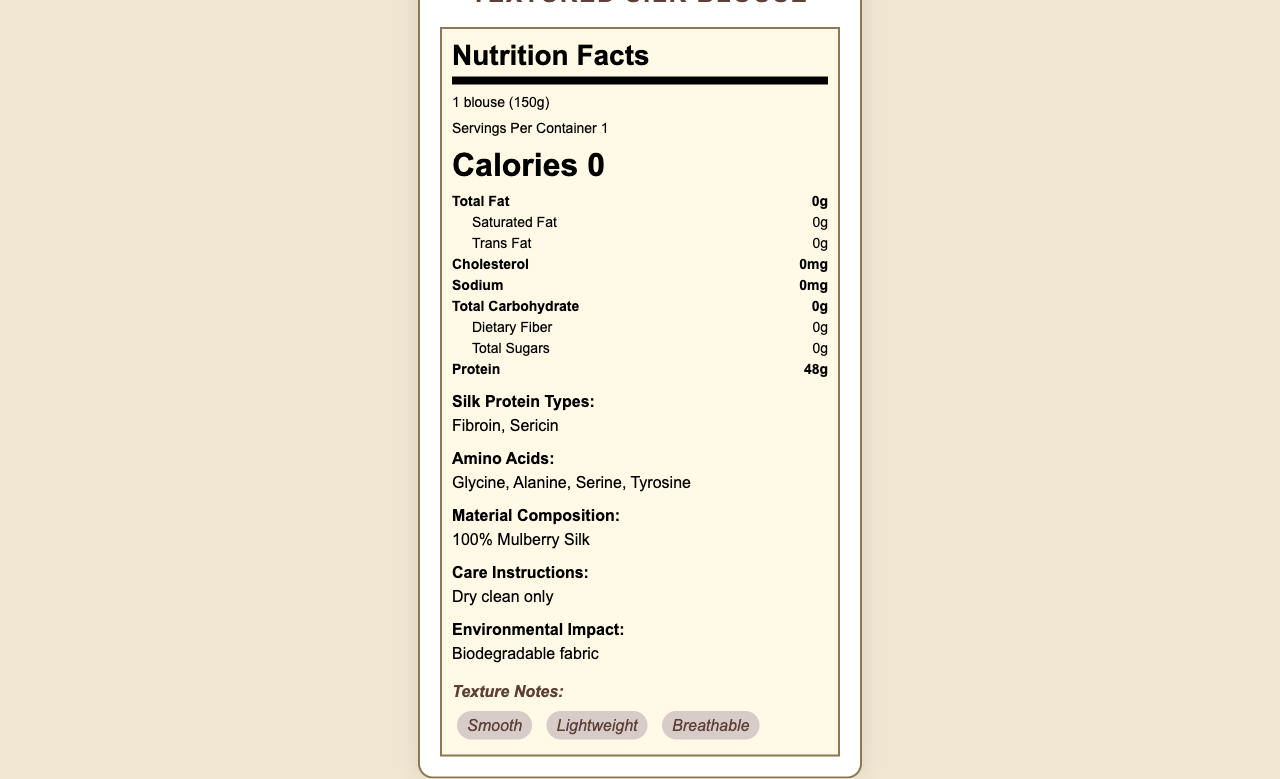what is the serving size of the Textured Silk Blouse? The serving size is explicitly mentioned at the top part of the nutrition label under the product name and nutrition facts header.
Answer: 1 blouse (150g) how much protein is in one serving? The amount of protein is listed under the nutrient section, showing "Protein 48g".
Answer: 48g are there any dietary fibers in this product? The nutrition label lists "Dietary Fiber" as 0g under the nutrient section.
Answer: No what are the main textures noted for the Textured Silk Blouse? The texture notes section highlights these properties accompanied by tags that describe smooth, lightweight, and breathable.
Answer: Smooth, Lightweight, Breathable what are the types of silk protein present? The section titled "Silk Protein Types" explicitly lists Fibroin and Sericin.
Answer: Fibroin, Sericin The Textured Silk Blouse contains which amino acids? The section titled "Amino Acids" lists these particular amino acids.
Answer: Glycine, Alanine, Serine, Tyrosine How many calories does the Textured Silk Blouse have? The calorie content is listed under the nutrition facts header and clearly states "Calories 0".
Answer: 0 Which of the following represents the correct material composition? A. 100% Cotton B. 50% Silk, 50% Cotton C. 100% Mulberry Silk The section titled "Material Composition" states the blouse is made of "100% Mulberry Silk".
Answer: C What is the care instruction provided for the Textured Silk Blouse? A. Machine wash only B. Hand-wash only C. Dry clean only The "Care Instructions" section mentions "Dry clean only".
Answer: C Is the Textured Silk Blouse hypoallergenic? The document includes a specific point mentioning that the blouse is hypoallergenic.
Answer: Yes Can the detailed origin of this product be determined? The section titled "Origin" states the exact origin of the product as "Ethically sourced from Suzhou, China".
Answer: Ethically sourced from Suzhou, China What is the environmental impact of the Textured Silk Blouse? The "Environmental Impact" section mentions that the fabric is biodegradable.
Answer: Biodegradable fabric Summarize the key nutritional information in the document. The summary focuses on the main nutritional content, highlighting the lack of typical nutrients found in food and emphasizing the high protein content and its composition.
Answer: The Textured Silk Blouse has no calories, fats, cholesterol, sodium, carbohydrates, sugars, or dietary fibers. However, it contains 48g of protein, comprising silk proteins like Fibroin and Sericin, with amino acids such as Glycine, Alanine, Serine, and Tyrosine. Is this product machine washable? The care instruction specified in the document says "Dry clean only," indicating it is not machine washable.
Answer: No How do the tactile properties of the silk blouse improve comfort? The tactile properties section highlights the soft texture, slight sheen, and natural temperature regulation for comfort.
Answer: The blouse is soft to touch, has a slight sheen, and provides natural temperature regulation, making it comfortable to wear in various conditions. Provide detailed instructions on how to clean the Textured Silk Blouse. The care instructions indicate that the blouse should be dry cleaned and no other cleaning methods are specified.
Answer: The Textured Silk Blouse should be dry cleaned only. Who is the manufacturer of the Textured Silk Blouse? The document does not mention the manufacturer, so the answer cannot be determined.
Answer: Not enough information How does the texture of the Textured Silk Blouse contribute to its design focus? The design focus section mentions that intricate textures and patterns are designed to be felt rather than seen, contributing to the blouse's unique design.
Answer: The intricate textures and patterns are discernable by touch, enhancing the tactile experience and aligning with the design focus on texture rather than color. What feature supports the claim that the Textured Silk Blouse is breathable? The texture notes section lists "Breathable" as one of the key texture properties of the blouse.
Answer: The texture notes specifically mention that the blouse is breathable. 